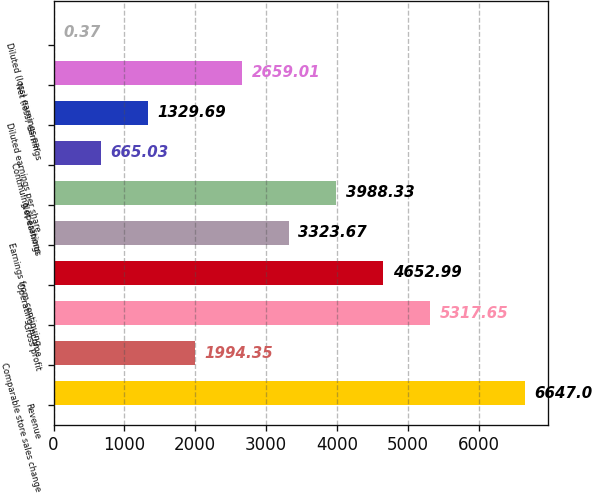<chart> <loc_0><loc_0><loc_500><loc_500><bar_chart><fcel>Revenue<fcel>Comparable store sales change<fcel>Gross profit<fcel>Operating income<fcel>Earnings from continuing<fcel>Net earnings<fcel>Continuing operations<fcel>Diluted earnings per share<fcel>Net (loss) earnings<fcel>Diluted (loss) earnings per<nl><fcel>6647<fcel>1994.35<fcel>5317.65<fcel>4652.99<fcel>3323.67<fcel>3988.33<fcel>665.03<fcel>1329.69<fcel>2659.01<fcel>0.37<nl></chart> 